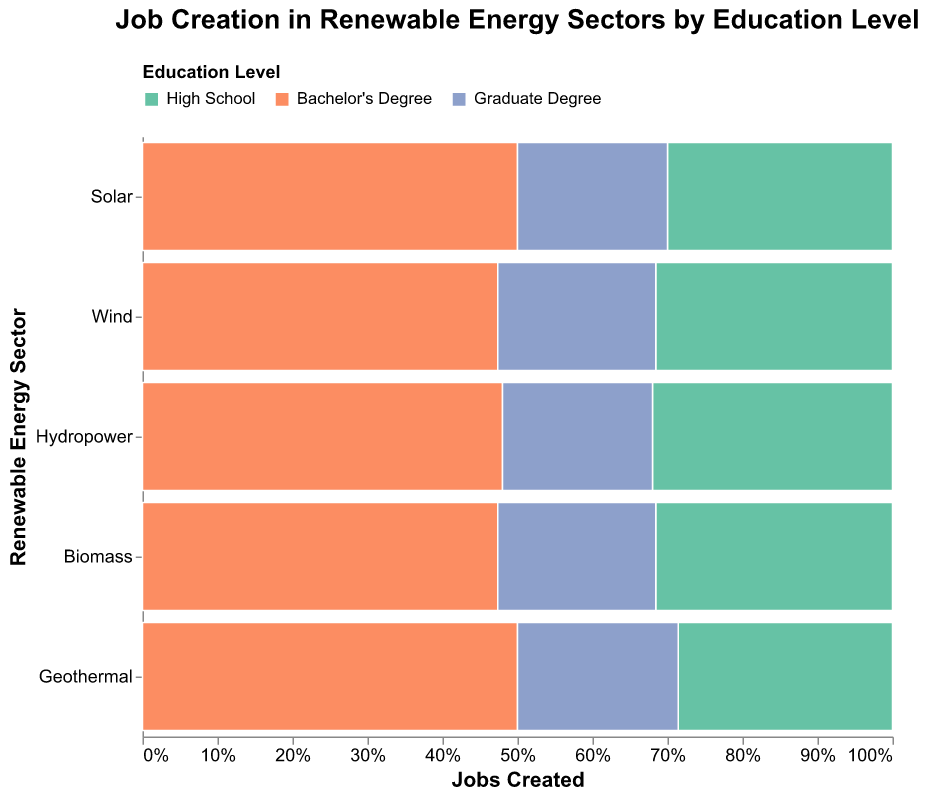Which renewable energy sector creates the most jobs for Bachelor's Degree holders? The axis "Jobs Created" indicates the total number of jobs created by education level in different sectors. From the color-coded mosaic plot, the largest section for Bachelor's Degree holders corresponds to the Solar sector.
Answer: Solar In which sector do Graduate Degree holders create the least number of jobs? Identify the smallest section (in terms of job creation) colored for Graduate Degree holders in the plot. The Geothermal sector has the smallest portion for Graduate Degree holders.
Answer: Geothermal Compare the job creation for High School graduates between the Wind and Biomass sectors. Which sector has more jobs created? Analyze the sections colored for High School graduates in both Wind and Biomass sectors. The plot shows that the Wind sector has a larger section compared to the Biomass sector for High School graduates.
Answer: Wind What is the total number of jobs created in the Hydropower sector? Sum the jobs created in all education levels within the Hydropower sector by visually inspecting the three sections (High School, Bachelor's Degree, Graduate Degree). 8000 (High School) + 12000 (Bachelor's) + 5000 (Graduate) = 25000 jobs.
Answer: 25000 Which education level has the highest job creation in the Solar sector? Determine the largest section within the Solar sector based on the colors indicating different education levels. Bachelor's Degree holders have the highest job creation in the Solar sector.
Answer: Bachelor's Degree What percentage of Biomass sector jobs is created by High School graduates? Find the section for High School graduates within the Biomass sector and compare this to the total jobs in the same sector. The tooltip shows the percentage: 6000 (High School) out of 19000 total jobs in Biomass, which is approximately 31.6%.
Answer: 31.6% Between the Solar and Wind sectors, which one has a higher job creation for Bachelor's Degree holders? Compare the job creation sections for Bachelor's Degree holders in both Solar and Wind sectors. The Solar sector has a larger job creation section for Bachelor's Degree holders.
Answer: Solar What is the proportion of jobs created by Graduate Degree holders in the Wind sector? Find the section for Graduate Degree holders in the Wind sector and recognize the proportion via the tooltip. The plot shows 8000 out of 38000 jobs in Wind, which makes the proportion approximately 21%.
Answer: 21% How many more jobs do Bachelor's Degree holders create in the Solar sector compared to the Hydropower sector? Subtract the number of jobs created by Bachelor's Degree holders in Hydropower from those in the Solar sector. 25000 (Solar) - 12000 (Hydropower) = 13000 more jobs.
Answer: 13000 Which renewable energy sector has the smallest total number of jobs created? Compare the total height of each sector on the y-axis. The Geothermal sector has the smallest total number of jobs created.
Answer: Geothermal 